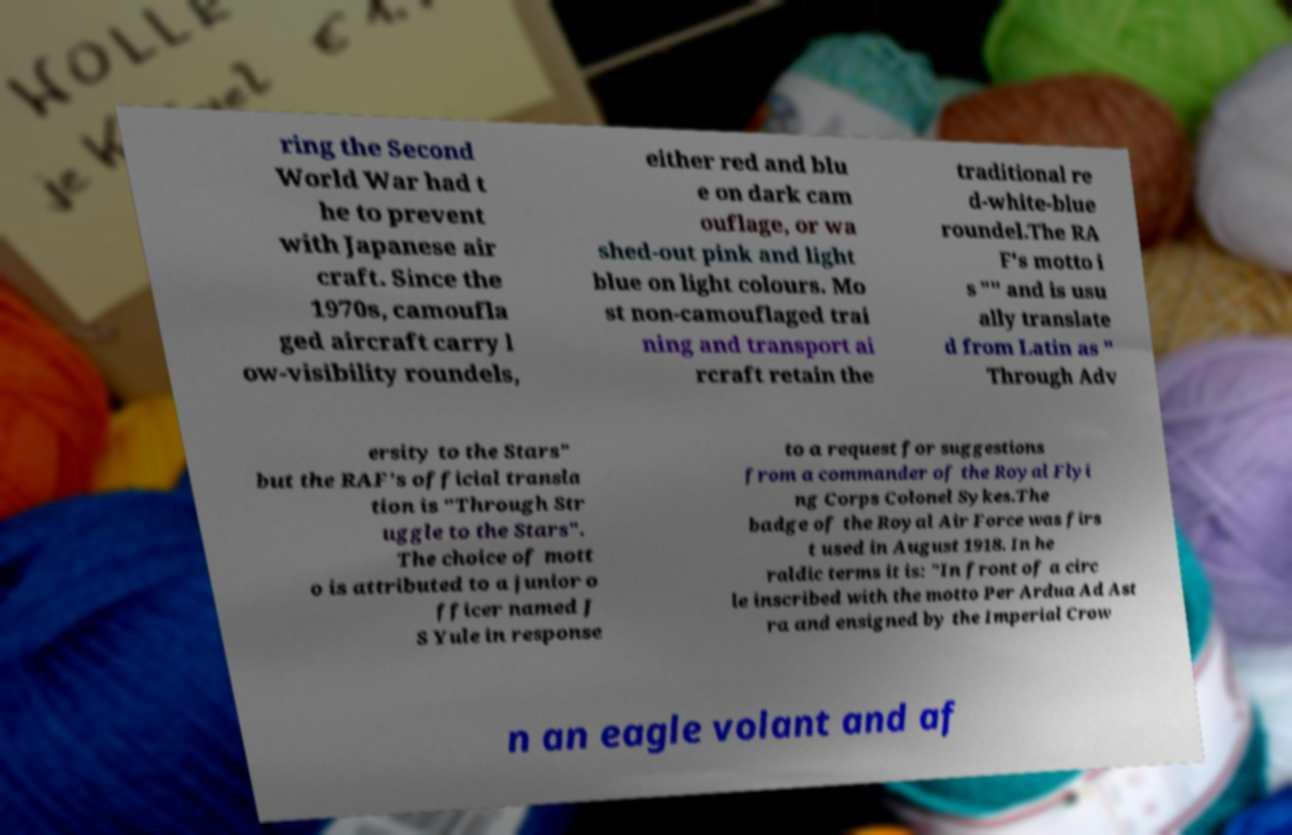There's text embedded in this image that I need extracted. Can you transcribe it verbatim? ring the Second World War had t he to prevent with Japanese air craft. Since the 1970s, camoufla ged aircraft carry l ow-visibility roundels, either red and blu e on dark cam ouflage, or wa shed-out pink and light blue on light colours. Mo st non-camouflaged trai ning and transport ai rcraft retain the traditional re d-white-blue roundel.The RA F's motto i s "" and is usu ally translate d from Latin as " Through Adv ersity to the Stars" but the RAF's official transla tion is "Through Str uggle to the Stars". The choice of mott o is attributed to a junior o fficer named J S Yule in response to a request for suggestions from a commander of the Royal Flyi ng Corps Colonel Sykes.The badge of the Royal Air Force was firs t used in August 1918. In he raldic terms it is: "In front of a circ le inscribed with the motto Per Ardua Ad Ast ra and ensigned by the Imperial Crow n an eagle volant and af 